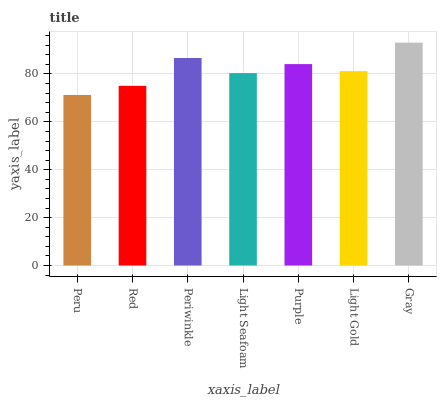Is Peru the minimum?
Answer yes or no. Yes. Is Gray the maximum?
Answer yes or no. Yes. Is Red the minimum?
Answer yes or no. No. Is Red the maximum?
Answer yes or no. No. Is Red greater than Peru?
Answer yes or no. Yes. Is Peru less than Red?
Answer yes or no. Yes. Is Peru greater than Red?
Answer yes or no. No. Is Red less than Peru?
Answer yes or no. No. Is Light Gold the high median?
Answer yes or no. Yes. Is Light Gold the low median?
Answer yes or no. Yes. Is Peru the high median?
Answer yes or no. No. Is Light Seafoam the low median?
Answer yes or no. No. 